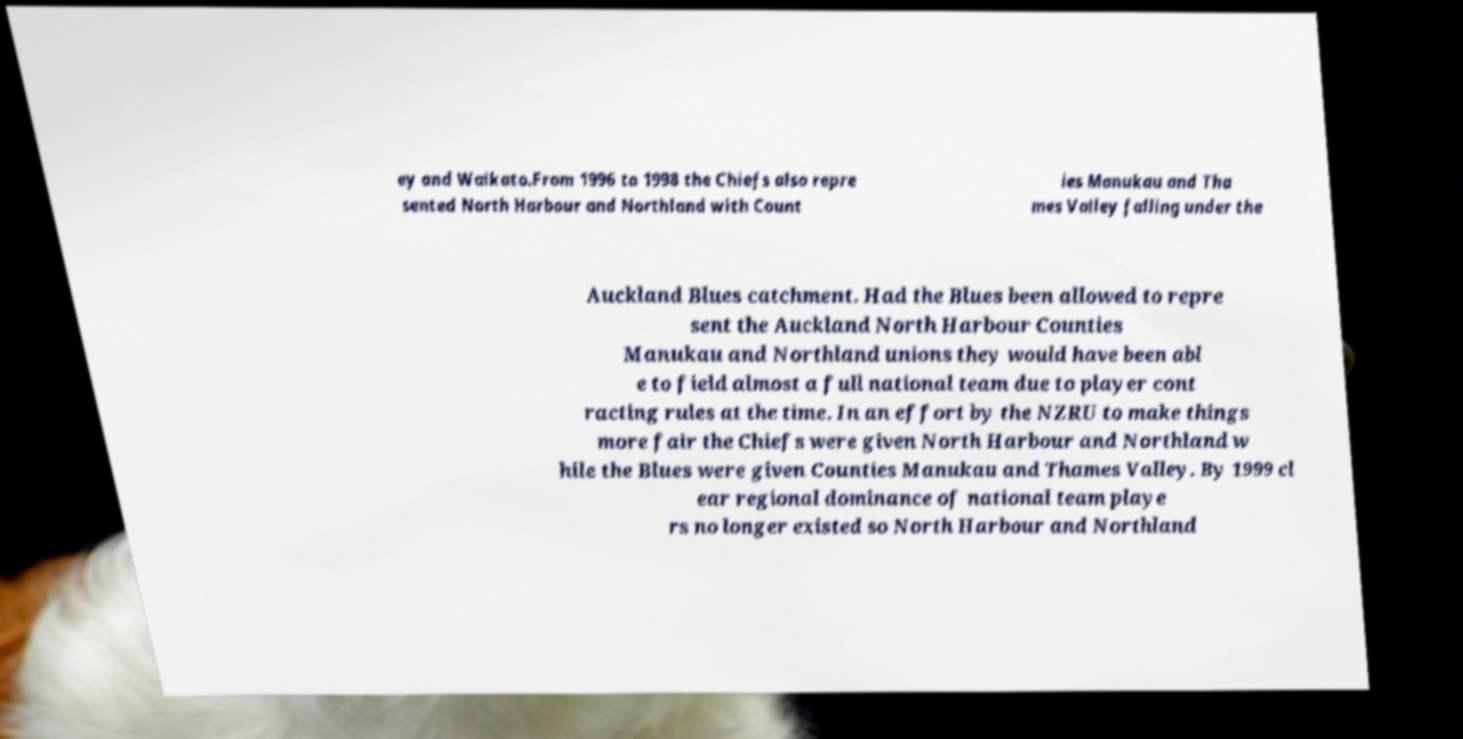Can you accurately transcribe the text from the provided image for me? ey and Waikato.From 1996 to 1998 the Chiefs also repre sented North Harbour and Northland with Count ies Manukau and Tha mes Valley falling under the Auckland Blues catchment. Had the Blues been allowed to repre sent the Auckland North Harbour Counties Manukau and Northland unions they would have been abl e to field almost a full national team due to player cont racting rules at the time. In an effort by the NZRU to make things more fair the Chiefs were given North Harbour and Northland w hile the Blues were given Counties Manukau and Thames Valley. By 1999 cl ear regional dominance of national team playe rs no longer existed so North Harbour and Northland 